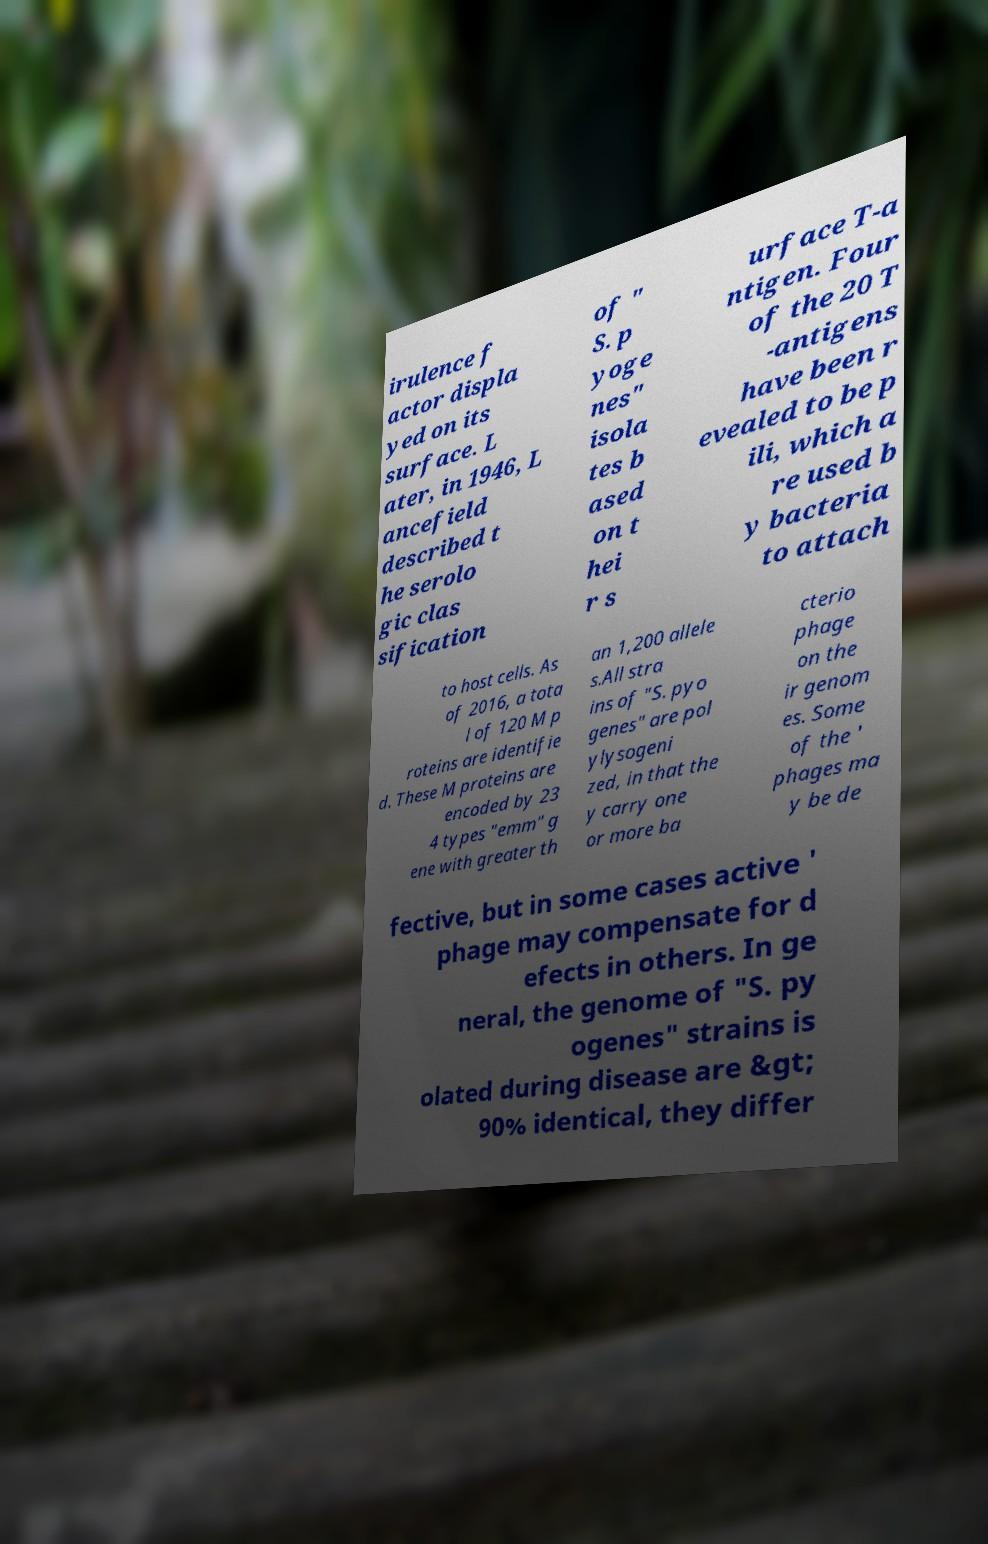There's text embedded in this image that I need extracted. Can you transcribe it verbatim? irulence f actor displa yed on its surface. L ater, in 1946, L ancefield described t he serolo gic clas sification of " S. p yoge nes" isola tes b ased on t hei r s urface T-a ntigen. Four of the 20 T -antigens have been r evealed to be p ili, which a re used b y bacteria to attach to host cells. As of 2016, a tota l of 120 M p roteins are identifie d. These M proteins are encoded by 23 4 types "emm" g ene with greater th an 1,200 allele s.All stra ins of "S. pyo genes" are pol ylysogeni zed, in that the y carry one or more ba cterio phage on the ir genom es. Some of the ' phages ma y be de fective, but in some cases active ' phage may compensate for d efects in others. In ge neral, the genome of "S. py ogenes" strains is olated during disease are &gt; 90% identical, they differ 